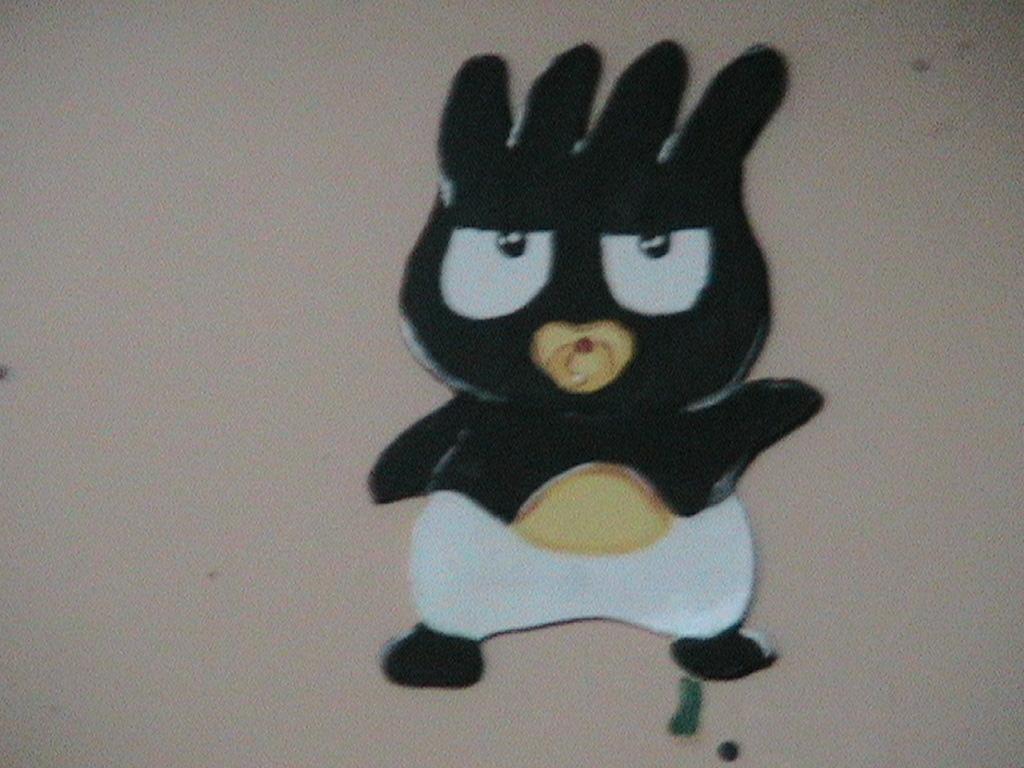In one or two sentences, can you explain what this image depicts? This is a zoomed in picture. In the center there is a black color cartoon. In the background there is an object seems to be the wall. 